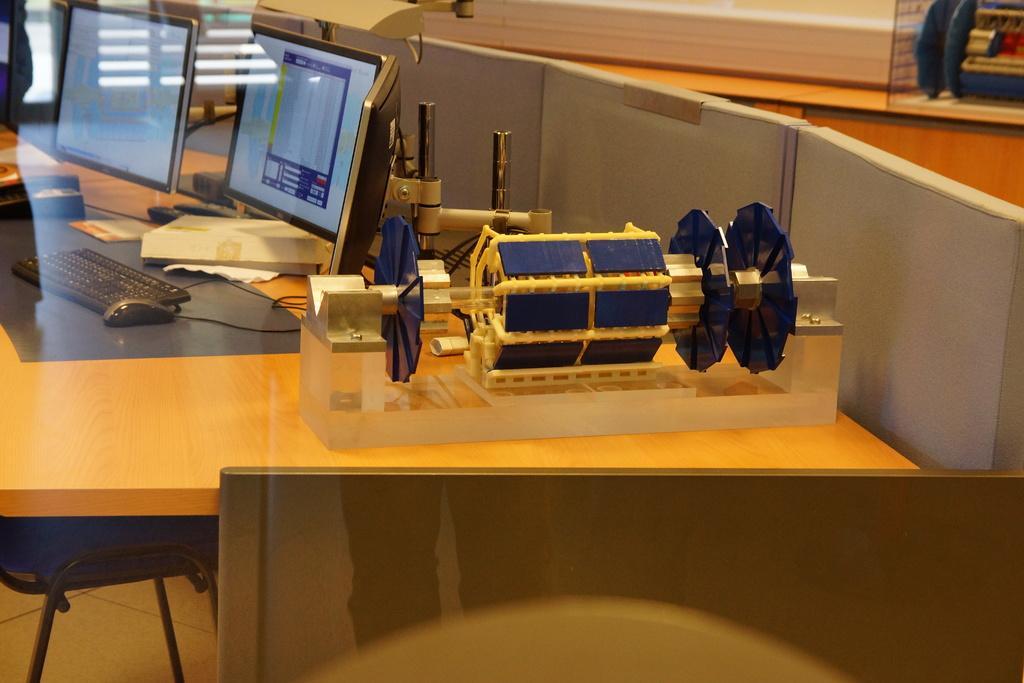Describe this image in one or two sentences. In this image I can see the cream colored surface and on it I can see few monitors, few keyboards, few wires and a machine which is blue and yellow in color. I can see a chair and few other objects in the blurry background. 